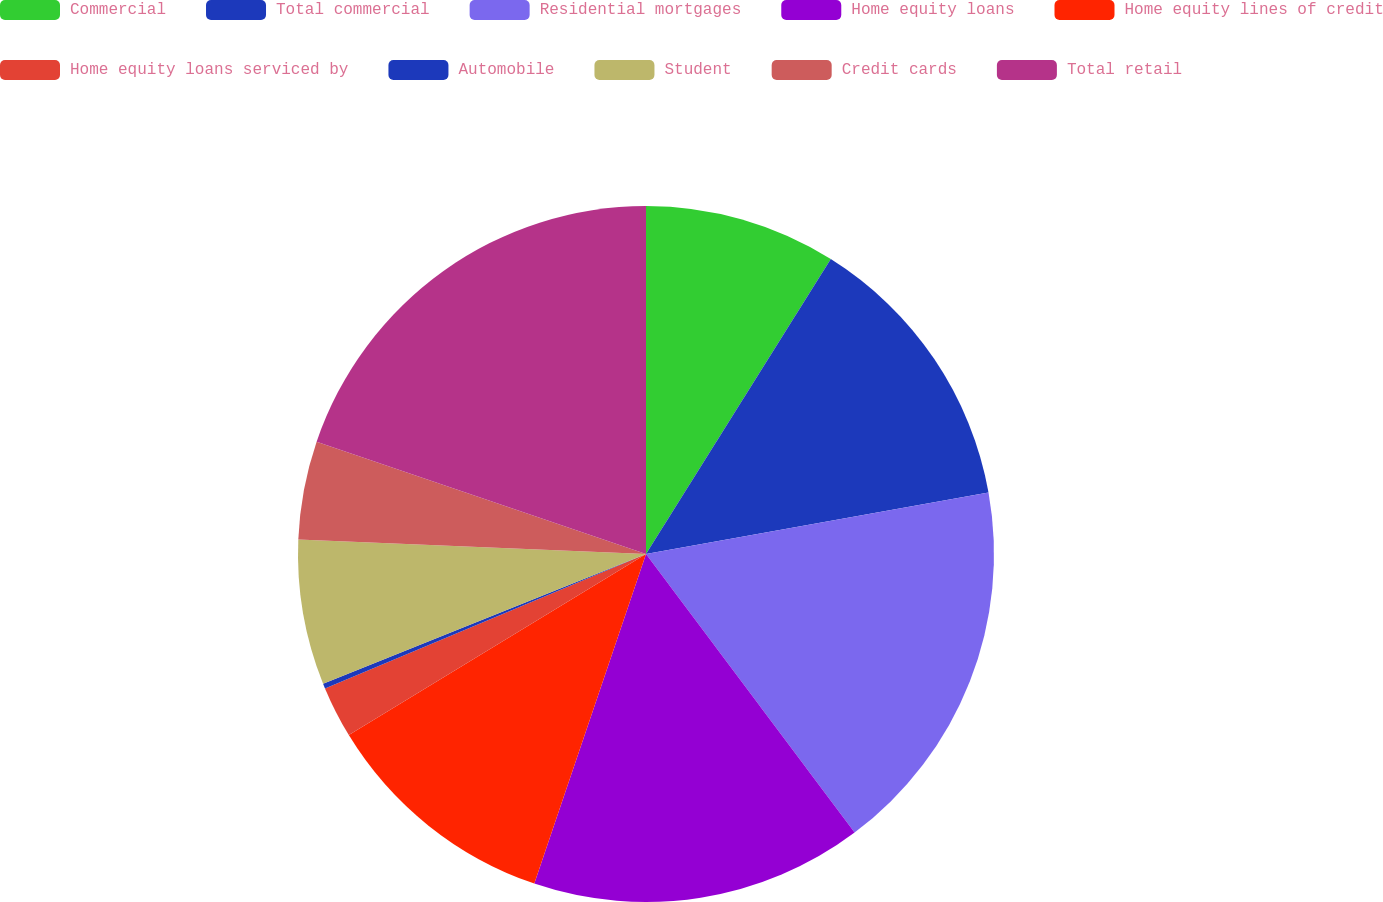Convert chart to OTSL. <chart><loc_0><loc_0><loc_500><loc_500><pie_chart><fcel>Commercial<fcel>Total commercial<fcel>Residential mortgages<fcel>Home equity loans<fcel>Home equity lines of credit<fcel>Home equity loans serviced by<fcel>Automobile<fcel>Student<fcel>Credit cards<fcel>Total retail<nl><fcel>8.91%<fcel>13.26%<fcel>17.6%<fcel>15.43%<fcel>11.09%<fcel>2.4%<fcel>0.23%<fcel>6.74%<fcel>4.57%<fcel>19.77%<nl></chart> 